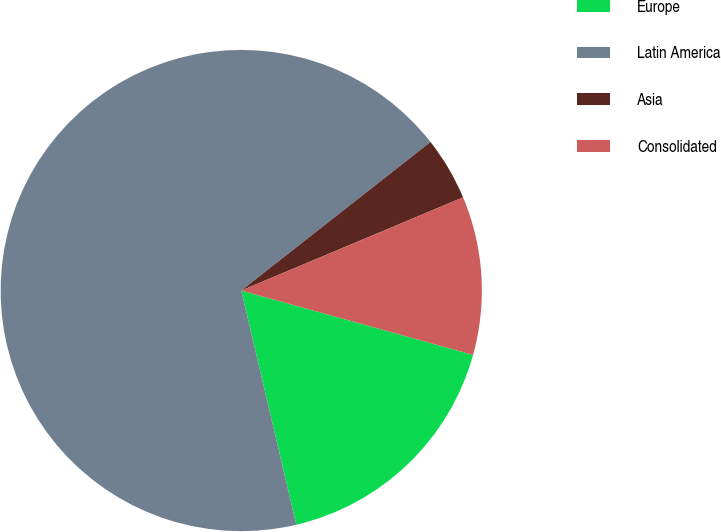Convert chart to OTSL. <chart><loc_0><loc_0><loc_500><loc_500><pie_chart><fcel>Europe<fcel>Latin America<fcel>Asia<fcel>Consolidated<nl><fcel>17.02%<fcel>68.09%<fcel>4.26%<fcel>10.64%<nl></chart> 